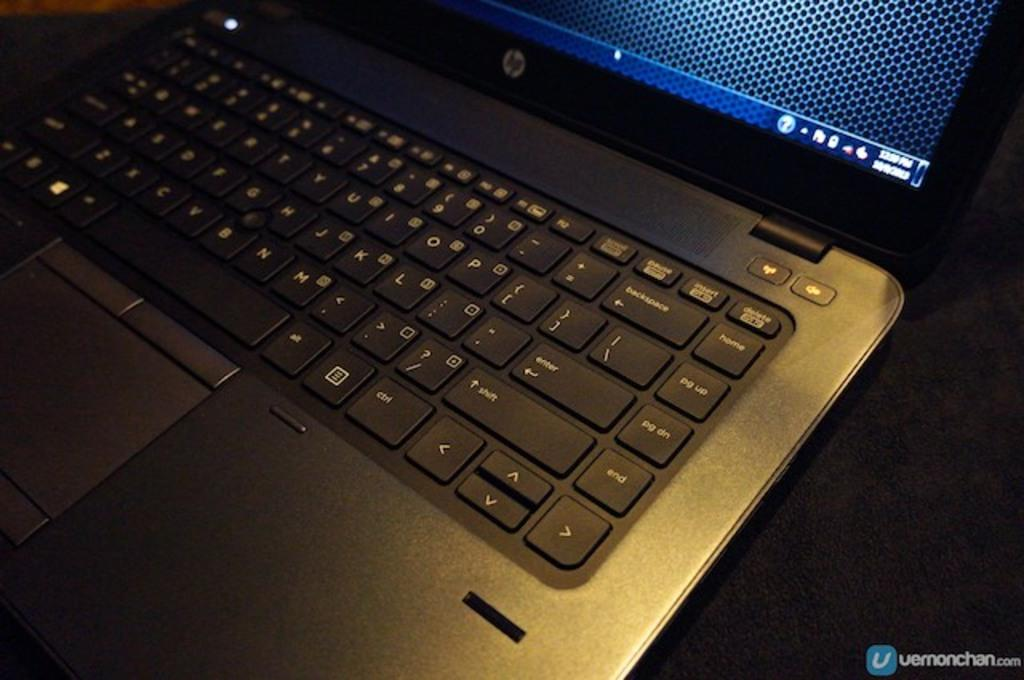<image>
Describe the image concisely. A black and silver hp laptop placed on a dark colored surface. 